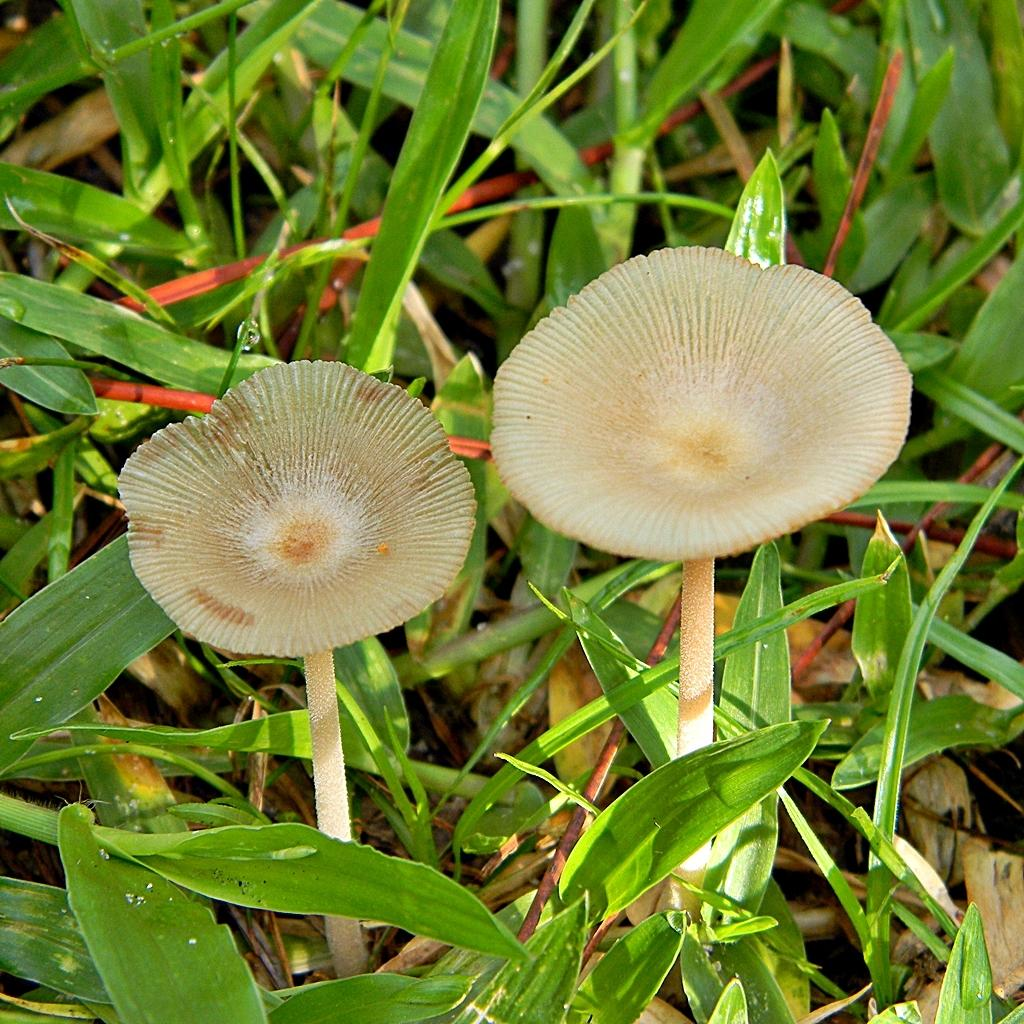What type of vegetation is present in the image? There are mushrooms and grass in the image. Can you describe the natural environment depicted in the image? The image features a natural environment with mushrooms and grass. What type of structure can be seen in the cellar in the image? There is no cellar or structure present in the image; it features mushrooms and grass in a natural environment. 